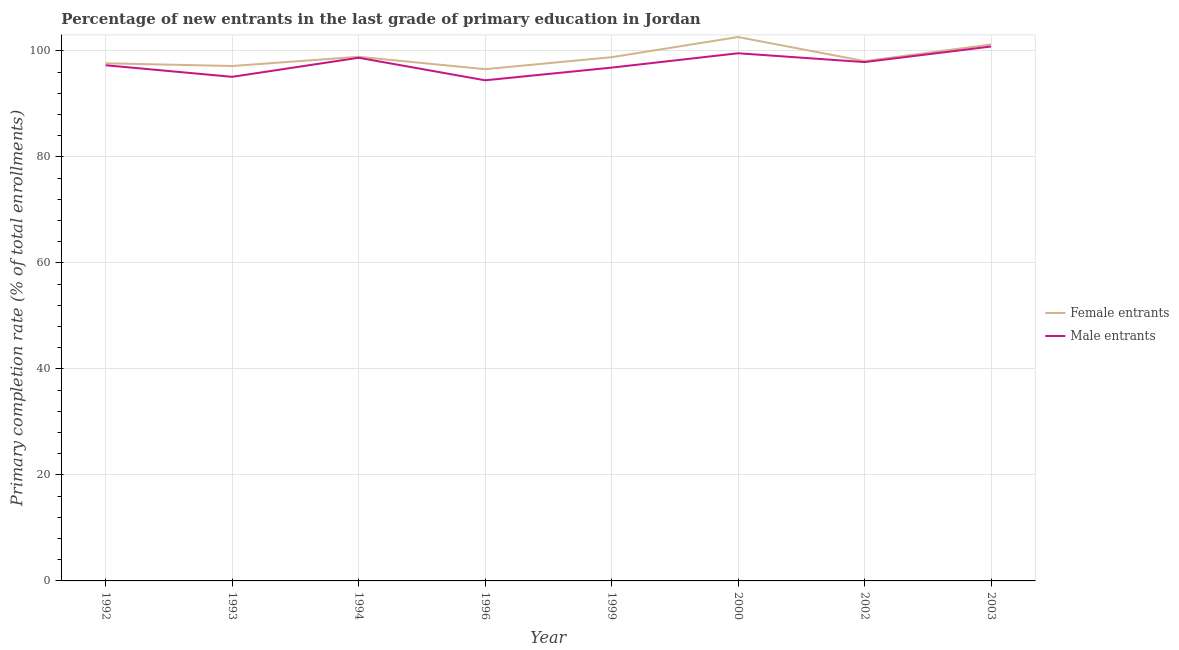How many different coloured lines are there?
Provide a succinct answer. 2. Does the line corresponding to primary completion rate of female entrants intersect with the line corresponding to primary completion rate of male entrants?
Your answer should be compact. No. Is the number of lines equal to the number of legend labels?
Make the answer very short. Yes. What is the primary completion rate of female entrants in 1999?
Provide a short and direct response. 98.8. Across all years, what is the maximum primary completion rate of female entrants?
Give a very brief answer. 102.6. Across all years, what is the minimum primary completion rate of female entrants?
Your answer should be compact. 96.54. In which year was the primary completion rate of male entrants maximum?
Offer a terse response. 2003. In which year was the primary completion rate of female entrants minimum?
Provide a succinct answer. 1996. What is the total primary completion rate of male entrants in the graph?
Keep it short and to the point. 780.58. What is the difference between the primary completion rate of male entrants in 1993 and that in 1999?
Offer a very short reply. -1.74. What is the difference between the primary completion rate of male entrants in 1992 and the primary completion rate of female entrants in 1993?
Make the answer very short. 0.14. What is the average primary completion rate of female entrants per year?
Your response must be concise. 98.86. In the year 1994, what is the difference between the primary completion rate of male entrants and primary completion rate of female entrants?
Offer a very short reply. -0.18. What is the ratio of the primary completion rate of male entrants in 1993 to that in 1996?
Ensure brevity in your answer.  1.01. What is the difference between the highest and the second highest primary completion rate of male entrants?
Provide a succinct answer. 1.28. What is the difference between the highest and the lowest primary completion rate of female entrants?
Give a very brief answer. 6.06. Is the primary completion rate of female entrants strictly greater than the primary completion rate of male entrants over the years?
Ensure brevity in your answer.  Yes. How many lines are there?
Ensure brevity in your answer.  2. What is the difference between two consecutive major ticks on the Y-axis?
Offer a terse response. 20. Does the graph contain any zero values?
Your answer should be compact. No. How many legend labels are there?
Give a very brief answer. 2. How are the legend labels stacked?
Provide a short and direct response. Vertical. What is the title of the graph?
Your response must be concise. Percentage of new entrants in the last grade of primary education in Jordan. What is the label or title of the X-axis?
Offer a very short reply. Year. What is the label or title of the Y-axis?
Ensure brevity in your answer.  Primary completion rate (% of total enrollments). What is the Primary completion rate (% of total enrollments) of Female entrants in 1992?
Your response must be concise. 97.65. What is the Primary completion rate (% of total enrollments) of Male entrants in 1992?
Provide a short and direct response. 97.28. What is the Primary completion rate (% of total enrollments) of Female entrants in 1993?
Make the answer very short. 97.14. What is the Primary completion rate (% of total enrollments) in Male entrants in 1993?
Your answer should be compact. 95.1. What is the Primary completion rate (% of total enrollments) in Female entrants in 1994?
Provide a succinct answer. 98.88. What is the Primary completion rate (% of total enrollments) of Male entrants in 1994?
Offer a very short reply. 98.69. What is the Primary completion rate (% of total enrollments) of Female entrants in 1996?
Ensure brevity in your answer.  96.54. What is the Primary completion rate (% of total enrollments) of Male entrants in 1996?
Provide a short and direct response. 94.44. What is the Primary completion rate (% of total enrollments) of Female entrants in 1999?
Your response must be concise. 98.8. What is the Primary completion rate (% of total enrollments) in Male entrants in 1999?
Make the answer very short. 96.83. What is the Primary completion rate (% of total enrollments) of Female entrants in 2000?
Ensure brevity in your answer.  102.6. What is the Primary completion rate (% of total enrollments) in Male entrants in 2000?
Ensure brevity in your answer.  99.54. What is the Primary completion rate (% of total enrollments) in Female entrants in 2002?
Offer a terse response. 98.06. What is the Primary completion rate (% of total enrollments) of Male entrants in 2002?
Offer a very short reply. 97.88. What is the Primary completion rate (% of total enrollments) of Female entrants in 2003?
Offer a very short reply. 101.21. What is the Primary completion rate (% of total enrollments) of Male entrants in 2003?
Give a very brief answer. 100.82. Across all years, what is the maximum Primary completion rate (% of total enrollments) in Female entrants?
Provide a succinct answer. 102.6. Across all years, what is the maximum Primary completion rate (% of total enrollments) of Male entrants?
Ensure brevity in your answer.  100.82. Across all years, what is the minimum Primary completion rate (% of total enrollments) of Female entrants?
Your answer should be very brief. 96.54. Across all years, what is the minimum Primary completion rate (% of total enrollments) in Male entrants?
Make the answer very short. 94.44. What is the total Primary completion rate (% of total enrollments) in Female entrants in the graph?
Keep it short and to the point. 790.87. What is the total Primary completion rate (% of total enrollments) of Male entrants in the graph?
Your answer should be very brief. 780.58. What is the difference between the Primary completion rate (% of total enrollments) of Female entrants in 1992 and that in 1993?
Your response must be concise. 0.51. What is the difference between the Primary completion rate (% of total enrollments) of Male entrants in 1992 and that in 1993?
Give a very brief answer. 2.18. What is the difference between the Primary completion rate (% of total enrollments) of Female entrants in 1992 and that in 1994?
Your answer should be very brief. -1.23. What is the difference between the Primary completion rate (% of total enrollments) in Male entrants in 1992 and that in 1994?
Your answer should be very brief. -1.41. What is the difference between the Primary completion rate (% of total enrollments) of Female entrants in 1992 and that in 1996?
Keep it short and to the point. 1.11. What is the difference between the Primary completion rate (% of total enrollments) in Male entrants in 1992 and that in 1996?
Keep it short and to the point. 2.84. What is the difference between the Primary completion rate (% of total enrollments) in Female entrants in 1992 and that in 1999?
Make the answer very short. -1.15. What is the difference between the Primary completion rate (% of total enrollments) in Male entrants in 1992 and that in 1999?
Your answer should be compact. 0.45. What is the difference between the Primary completion rate (% of total enrollments) in Female entrants in 1992 and that in 2000?
Your answer should be very brief. -4.95. What is the difference between the Primary completion rate (% of total enrollments) in Male entrants in 1992 and that in 2000?
Your answer should be very brief. -2.26. What is the difference between the Primary completion rate (% of total enrollments) in Female entrants in 1992 and that in 2002?
Your response must be concise. -0.4. What is the difference between the Primary completion rate (% of total enrollments) of Male entrants in 1992 and that in 2002?
Provide a short and direct response. -0.6. What is the difference between the Primary completion rate (% of total enrollments) in Female entrants in 1992 and that in 2003?
Give a very brief answer. -3.55. What is the difference between the Primary completion rate (% of total enrollments) in Male entrants in 1992 and that in 2003?
Provide a succinct answer. -3.54. What is the difference between the Primary completion rate (% of total enrollments) in Female entrants in 1993 and that in 1994?
Provide a short and direct response. -1.74. What is the difference between the Primary completion rate (% of total enrollments) of Male entrants in 1993 and that in 1994?
Keep it short and to the point. -3.6. What is the difference between the Primary completion rate (% of total enrollments) of Female entrants in 1993 and that in 1996?
Your answer should be compact. 0.6. What is the difference between the Primary completion rate (% of total enrollments) of Male entrants in 1993 and that in 1996?
Your response must be concise. 0.65. What is the difference between the Primary completion rate (% of total enrollments) in Female entrants in 1993 and that in 1999?
Your answer should be very brief. -1.66. What is the difference between the Primary completion rate (% of total enrollments) of Male entrants in 1993 and that in 1999?
Keep it short and to the point. -1.74. What is the difference between the Primary completion rate (% of total enrollments) of Female entrants in 1993 and that in 2000?
Give a very brief answer. -5.46. What is the difference between the Primary completion rate (% of total enrollments) of Male entrants in 1993 and that in 2000?
Offer a very short reply. -4.44. What is the difference between the Primary completion rate (% of total enrollments) of Female entrants in 1993 and that in 2002?
Ensure brevity in your answer.  -0.92. What is the difference between the Primary completion rate (% of total enrollments) in Male entrants in 1993 and that in 2002?
Your response must be concise. -2.78. What is the difference between the Primary completion rate (% of total enrollments) of Female entrants in 1993 and that in 2003?
Ensure brevity in your answer.  -4.07. What is the difference between the Primary completion rate (% of total enrollments) of Male entrants in 1993 and that in 2003?
Provide a succinct answer. -5.72. What is the difference between the Primary completion rate (% of total enrollments) of Female entrants in 1994 and that in 1996?
Your answer should be very brief. 2.34. What is the difference between the Primary completion rate (% of total enrollments) of Male entrants in 1994 and that in 1996?
Provide a short and direct response. 4.25. What is the difference between the Primary completion rate (% of total enrollments) in Female entrants in 1994 and that in 1999?
Keep it short and to the point. 0.08. What is the difference between the Primary completion rate (% of total enrollments) in Male entrants in 1994 and that in 1999?
Make the answer very short. 1.86. What is the difference between the Primary completion rate (% of total enrollments) of Female entrants in 1994 and that in 2000?
Provide a short and direct response. -3.72. What is the difference between the Primary completion rate (% of total enrollments) of Male entrants in 1994 and that in 2000?
Your answer should be compact. -0.85. What is the difference between the Primary completion rate (% of total enrollments) of Female entrants in 1994 and that in 2002?
Your response must be concise. 0.82. What is the difference between the Primary completion rate (% of total enrollments) in Male entrants in 1994 and that in 2002?
Offer a terse response. 0.82. What is the difference between the Primary completion rate (% of total enrollments) of Female entrants in 1994 and that in 2003?
Make the answer very short. -2.33. What is the difference between the Primary completion rate (% of total enrollments) in Male entrants in 1994 and that in 2003?
Your response must be concise. -2.12. What is the difference between the Primary completion rate (% of total enrollments) of Female entrants in 1996 and that in 1999?
Provide a short and direct response. -2.26. What is the difference between the Primary completion rate (% of total enrollments) of Male entrants in 1996 and that in 1999?
Keep it short and to the point. -2.39. What is the difference between the Primary completion rate (% of total enrollments) in Female entrants in 1996 and that in 2000?
Offer a terse response. -6.06. What is the difference between the Primary completion rate (% of total enrollments) of Male entrants in 1996 and that in 2000?
Your response must be concise. -5.1. What is the difference between the Primary completion rate (% of total enrollments) of Female entrants in 1996 and that in 2002?
Keep it short and to the point. -1.52. What is the difference between the Primary completion rate (% of total enrollments) of Male entrants in 1996 and that in 2002?
Your answer should be compact. -3.43. What is the difference between the Primary completion rate (% of total enrollments) in Female entrants in 1996 and that in 2003?
Your answer should be very brief. -4.67. What is the difference between the Primary completion rate (% of total enrollments) in Male entrants in 1996 and that in 2003?
Keep it short and to the point. -6.37. What is the difference between the Primary completion rate (% of total enrollments) in Female entrants in 1999 and that in 2000?
Your answer should be very brief. -3.8. What is the difference between the Primary completion rate (% of total enrollments) of Male entrants in 1999 and that in 2000?
Your response must be concise. -2.71. What is the difference between the Primary completion rate (% of total enrollments) of Female entrants in 1999 and that in 2002?
Provide a succinct answer. 0.74. What is the difference between the Primary completion rate (% of total enrollments) of Male entrants in 1999 and that in 2002?
Your answer should be very brief. -1.04. What is the difference between the Primary completion rate (% of total enrollments) of Female entrants in 1999 and that in 2003?
Offer a terse response. -2.41. What is the difference between the Primary completion rate (% of total enrollments) of Male entrants in 1999 and that in 2003?
Your response must be concise. -3.98. What is the difference between the Primary completion rate (% of total enrollments) in Female entrants in 2000 and that in 2002?
Give a very brief answer. 4.54. What is the difference between the Primary completion rate (% of total enrollments) in Male entrants in 2000 and that in 2002?
Keep it short and to the point. 1.66. What is the difference between the Primary completion rate (% of total enrollments) in Female entrants in 2000 and that in 2003?
Your answer should be compact. 1.4. What is the difference between the Primary completion rate (% of total enrollments) in Male entrants in 2000 and that in 2003?
Provide a succinct answer. -1.28. What is the difference between the Primary completion rate (% of total enrollments) in Female entrants in 2002 and that in 2003?
Ensure brevity in your answer.  -3.15. What is the difference between the Primary completion rate (% of total enrollments) of Male entrants in 2002 and that in 2003?
Keep it short and to the point. -2.94. What is the difference between the Primary completion rate (% of total enrollments) of Female entrants in 1992 and the Primary completion rate (% of total enrollments) of Male entrants in 1993?
Provide a succinct answer. 2.56. What is the difference between the Primary completion rate (% of total enrollments) of Female entrants in 1992 and the Primary completion rate (% of total enrollments) of Male entrants in 1994?
Provide a succinct answer. -1.04. What is the difference between the Primary completion rate (% of total enrollments) of Female entrants in 1992 and the Primary completion rate (% of total enrollments) of Male entrants in 1996?
Make the answer very short. 3.21. What is the difference between the Primary completion rate (% of total enrollments) of Female entrants in 1992 and the Primary completion rate (% of total enrollments) of Male entrants in 1999?
Make the answer very short. 0.82. What is the difference between the Primary completion rate (% of total enrollments) of Female entrants in 1992 and the Primary completion rate (% of total enrollments) of Male entrants in 2000?
Provide a short and direct response. -1.89. What is the difference between the Primary completion rate (% of total enrollments) in Female entrants in 1992 and the Primary completion rate (% of total enrollments) in Male entrants in 2002?
Provide a succinct answer. -0.22. What is the difference between the Primary completion rate (% of total enrollments) of Female entrants in 1992 and the Primary completion rate (% of total enrollments) of Male entrants in 2003?
Make the answer very short. -3.16. What is the difference between the Primary completion rate (% of total enrollments) of Female entrants in 1993 and the Primary completion rate (% of total enrollments) of Male entrants in 1994?
Provide a short and direct response. -1.56. What is the difference between the Primary completion rate (% of total enrollments) of Female entrants in 1993 and the Primary completion rate (% of total enrollments) of Male entrants in 1996?
Keep it short and to the point. 2.7. What is the difference between the Primary completion rate (% of total enrollments) of Female entrants in 1993 and the Primary completion rate (% of total enrollments) of Male entrants in 1999?
Offer a terse response. 0.3. What is the difference between the Primary completion rate (% of total enrollments) of Female entrants in 1993 and the Primary completion rate (% of total enrollments) of Male entrants in 2000?
Your answer should be compact. -2.4. What is the difference between the Primary completion rate (% of total enrollments) of Female entrants in 1993 and the Primary completion rate (% of total enrollments) of Male entrants in 2002?
Provide a short and direct response. -0.74. What is the difference between the Primary completion rate (% of total enrollments) in Female entrants in 1993 and the Primary completion rate (% of total enrollments) in Male entrants in 2003?
Make the answer very short. -3.68. What is the difference between the Primary completion rate (% of total enrollments) of Female entrants in 1994 and the Primary completion rate (% of total enrollments) of Male entrants in 1996?
Give a very brief answer. 4.44. What is the difference between the Primary completion rate (% of total enrollments) in Female entrants in 1994 and the Primary completion rate (% of total enrollments) in Male entrants in 1999?
Provide a succinct answer. 2.04. What is the difference between the Primary completion rate (% of total enrollments) in Female entrants in 1994 and the Primary completion rate (% of total enrollments) in Male entrants in 2000?
Keep it short and to the point. -0.66. What is the difference between the Primary completion rate (% of total enrollments) of Female entrants in 1994 and the Primary completion rate (% of total enrollments) of Male entrants in 2002?
Make the answer very short. 1. What is the difference between the Primary completion rate (% of total enrollments) of Female entrants in 1994 and the Primary completion rate (% of total enrollments) of Male entrants in 2003?
Offer a very short reply. -1.94. What is the difference between the Primary completion rate (% of total enrollments) in Female entrants in 1996 and the Primary completion rate (% of total enrollments) in Male entrants in 1999?
Offer a very short reply. -0.29. What is the difference between the Primary completion rate (% of total enrollments) of Female entrants in 1996 and the Primary completion rate (% of total enrollments) of Male entrants in 2000?
Provide a short and direct response. -3. What is the difference between the Primary completion rate (% of total enrollments) of Female entrants in 1996 and the Primary completion rate (% of total enrollments) of Male entrants in 2002?
Your answer should be very brief. -1.34. What is the difference between the Primary completion rate (% of total enrollments) in Female entrants in 1996 and the Primary completion rate (% of total enrollments) in Male entrants in 2003?
Keep it short and to the point. -4.28. What is the difference between the Primary completion rate (% of total enrollments) of Female entrants in 1999 and the Primary completion rate (% of total enrollments) of Male entrants in 2000?
Provide a short and direct response. -0.74. What is the difference between the Primary completion rate (% of total enrollments) of Female entrants in 1999 and the Primary completion rate (% of total enrollments) of Male entrants in 2002?
Provide a succinct answer. 0.92. What is the difference between the Primary completion rate (% of total enrollments) of Female entrants in 1999 and the Primary completion rate (% of total enrollments) of Male entrants in 2003?
Offer a terse response. -2.02. What is the difference between the Primary completion rate (% of total enrollments) of Female entrants in 2000 and the Primary completion rate (% of total enrollments) of Male entrants in 2002?
Provide a succinct answer. 4.73. What is the difference between the Primary completion rate (% of total enrollments) in Female entrants in 2000 and the Primary completion rate (% of total enrollments) in Male entrants in 2003?
Provide a succinct answer. 1.79. What is the difference between the Primary completion rate (% of total enrollments) in Female entrants in 2002 and the Primary completion rate (% of total enrollments) in Male entrants in 2003?
Keep it short and to the point. -2.76. What is the average Primary completion rate (% of total enrollments) of Female entrants per year?
Provide a short and direct response. 98.86. What is the average Primary completion rate (% of total enrollments) in Male entrants per year?
Ensure brevity in your answer.  97.57. In the year 1992, what is the difference between the Primary completion rate (% of total enrollments) in Female entrants and Primary completion rate (% of total enrollments) in Male entrants?
Offer a very short reply. 0.37. In the year 1993, what is the difference between the Primary completion rate (% of total enrollments) in Female entrants and Primary completion rate (% of total enrollments) in Male entrants?
Your response must be concise. 2.04. In the year 1994, what is the difference between the Primary completion rate (% of total enrollments) of Female entrants and Primary completion rate (% of total enrollments) of Male entrants?
Make the answer very short. 0.18. In the year 1996, what is the difference between the Primary completion rate (% of total enrollments) of Female entrants and Primary completion rate (% of total enrollments) of Male entrants?
Provide a short and direct response. 2.1. In the year 1999, what is the difference between the Primary completion rate (% of total enrollments) in Female entrants and Primary completion rate (% of total enrollments) in Male entrants?
Give a very brief answer. 1.97. In the year 2000, what is the difference between the Primary completion rate (% of total enrollments) of Female entrants and Primary completion rate (% of total enrollments) of Male entrants?
Your answer should be very brief. 3.06. In the year 2002, what is the difference between the Primary completion rate (% of total enrollments) of Female entrants and Primary completion rate (% of total enrollments) of Male entrants?
Make the answer very short. 0.18. In the year 2003, what is the difference between the Primary completion rate (% of total enrollments) of Female entrants and Primary completion rate (% of total enrollments) of Male entrants?
Make the answer very short. 0.39. What is the ratio of the Primary completion rate (% of total enrollments) of Female entrants in 1992 to that in 1993?
Your answer should be very brief. 1.01. What is the ratio of the Primary completion rate (% of total enrollments) in Male entrants in 1992 to that in 1993?
Make the answer very short. 1.02. What is the ratio of the Primary completion rate (% of total enrollments) of Female entrants in 1992 to that in 1994?
Offer a terse response. 0.99. What is the ratio of the Primary completion rate (% of total enrollments) of Male entrants in 1992 to that in 1994?
Ensure brevity in your answer.  0.99. What is the ratio of the Primary completion rate (% of total enrollments) in Female entrants in 1992 to that in 1996?
Provide a short and direct response. 1.01. What is the ratio of the Primary completion rate (% of total enrollments) in Male entrants in 1992 to that in 1996?
Offer a terse response. 1.03. What is the ratio of the Primary completion rate (% of total enrollments) of Female entrants in 1992 to that in 1999?
Ensure brevity in your answer.  0.99. What is the ratio of the Primary completion rate (% of total enrollments) in Female entrants in 1992 to that in 2000?
Provide a succinct answer. 0.95. What is the ratio of the Primary completion rate (% of total enrollments) of Male entrants in 1992 to that in 2000?
Make the answer very short. 0.98. What is the ratio of the Primary completion rate (% of total enrollments) in Male entrants in 1992 to that in 2002?
Offer a terse response. 0.99. What is the ratio of the Primary completion rate (% of total enrollments) of Female entrants in 1992 to that in 2003?
Your answer should be very brief. 0.96. What is the ratio of the Primary completion rate (% of total enrollments) in Male entrants in 1992 to that in 2003?
Offer a very short reply. 0.96. What is the ratio of the Primary completion rate (% of total enrollments) in Female entrants in 1993 to that in 1994?
Your answer should be compact. 0.98. What is the ratio of the Primary completion rate (% of total enrollments) in Male entrants in 1993 to that in 1994?
Your response must be concise. 0.96. What is the ratio of the Primary completion rate (% of total enrollments) in Male entrants in 1993 to that in 1996?
Make the answer very short. 1.01. What is the ratio of the Primary completion rate (% of total enrollments) of Female entrants in 1993 to that in 1999?
Your answer should be very brief. 0.98. What is the ratio of the Primary completion rate (% of total enrollments) of Male entrants in 1993 to that in 1999?
Your answer should be very brief. 0.98. What is the ratio of the Primary completion rate (% of total enrollments) in Female entrants in 1993 to that in 2000?
Your answer should be compact. 0.95. What is the ratio of the Primary completion rate (% of total enrollments) in Male entrants in 1993 to that in 2000?
Keep it short and to the point. 0.96. What is the ratio of the Primary completion rate (% of total enrollments) in Female entrants in 1993 to that in 2002?
Keep it short and to the point. 0.99. What is the ratio of the Primary completion rate (% of total enrollments) of Male entrants in 1993 to that in 2002?
Your answer should be very brief. 0.97. What is the ratio of the Primary completion rate (% of total enrollments) of Female entrants in 1993 to that in 2003?
Provide a short and direct response. 0.96. What is the ratio of the Primary completion rate (% of total enrollments) of Male entrants in 1993 to that in 2003?
Give a very brief answer. 0.94. What is the ratio of the Primary completion rate (% of total enrollments) in Female entrants in 1994 to that in 1996?
Make the answer very short. 1.02. What is the ratio of the Primary completion rate (% of total enrollments) of Male entrants in 1994 to that in 1996?
Your response must be concise. 1.04. What is the ratio of the Primary completion rate (% of total enrollments) of Female entrants in 1994 to that in 1999?
Offer a very short reply. 1. What is the ratio of the Primary completion rate (% of total enrollments) of Male entrants in 1994 to that in 1999?
Provide a short and direct response. 1.02. What is the ratio of the Primary completion rate (% of total enrollments) in Female entrants in 1994 to that in 2000?
Your answer should be compact. 0.96. What is the ratio of the Primary completion rate (% of total enrollments) of Female entrants in 1994 to that in 2002?
Your answer should be very brief. 1.01. What is the ratio of the Primary completion rate (% of total enrollments) of Male entrants in 1994 to that in 2002?
Provide a short and direct response. 1.01. What is the ratio of the Primary completion rate (% of total enrollments) of Female entrants in 1994 to that in 2003?
Ensure brevity in your answer.  0.98. What is the ratio of the Primary completion rate (% of total enrollments) in Male entrants in 1994 to that in 2003?
Provide a short and direct response. 0.98. What is the ratio of the Primary completion rate (% of total enrollments) of Female entrants in 1996 to that in 1999?
Your answer should be compact. 0.98. What is the ratio of the Primary completion rate (% of total enrollments) in Male entrants in 1996 to that in 1999?
Your answer should be very brief. 0.98. What is the ratio of the Primary completion rate (% of total enrollments) in Female entrants in 1996 to that in 2000?
Your answer should be very brief. 0.94. What is the ratio of the Primary completion rate (% of total enrollments) of Male entrants in 1996 to that in 2000?
Give a very brief answer. 0.95. What is the ratio of the Primary completion rate (% of total enrollments) of Female entrants in 1996 to that in 2002?
Make the answer very short. 0.98. What is the ratio of the Primary completion rate (% of total enrollments) of Male entrants in 1996 to that in 2002?
Your response must be concise. 0.96. What is the ratio of the Primary completion rate (% of total enrollments) of Female entrants in 1996 to that in 2003?
Your answer should be compact. 0.95. What is the ratio of the Primary completion rate (% of total enrollments) of Male entrants in 1996 to that in 2003?
Keep it short and to the point. 0.94. What is the ratio of the Primary completion rate (% of total enrollments) in Female entrants in 1999 to that in 2000?
Ensure brevity in your answer.  0.96. What is the ratio of the Primary completion rate (% of total enrollments) of Male entrants in 1999 to that in 2000?
Make the answer very short. 0.97. What is the ratio of the Primary completion rate (% of total enrollments) in Female entrants in 1999 to that in 2002?
Make the answer very short. 1.01. What is the ratio of the Primary completion rate (% of total enrollments) in Male entrants in 1999 to that in 2002?
Your response must be concise. 0.99. What is the ratio of the Primary completion rate (% of total enrollments) in Female entrants in 1999 to that in 2003?
Make the answer very short. 0.98. What is the ratio of the Primary completion rate (% of total enrollments) in Male entrants in 1999 to that in 2003?
Offer a very short reply. 0.96. What is the ratio of the Primary completion rate (% of total enrollments) in Female entrants in 2000 to that in 2002?
Ensure brevity in your answer.  1.05. What is the ratio of the Primary completion rate (% of total enrollments) in Female entrants in 2000 to that in 2003?
Ensure brevity in your answer.  1.01. What is the ratio of the Primary completion rate (% of total enrollments) in Male entrants in 2000 to that in 2003?
Your response must be concise. 0.99. What is the ratio of the Primary completion rate (% of total enrollments) of Female entrants in 2002 to that in 2003?
Keep it short and to the point. 0.97. What is the ratio of the Primary completion rate (% of total enrollments) in Male entrants in 2002 to that in 2003?
Offer a very short reply. 0.97. What is the difference between the highest and the second highest Primary completion rate (% of total enrollments) in Female entrants?
Make the answer very short. 1.4. What is the difference between the highest and the second highest Primary completion rate (% of total enrollments) in Male entrants?
Your response must be concise. 1.28. What is the difference between the highest and the lowest Primary completion rate (% of total enrollments) in Female entrants?
Your answer should be compact. 6.06. What is the difference between the highest and the lowest Primary completion rate (% of total enrollments) of Male entrants?
Make the answer very short. 6.37. 